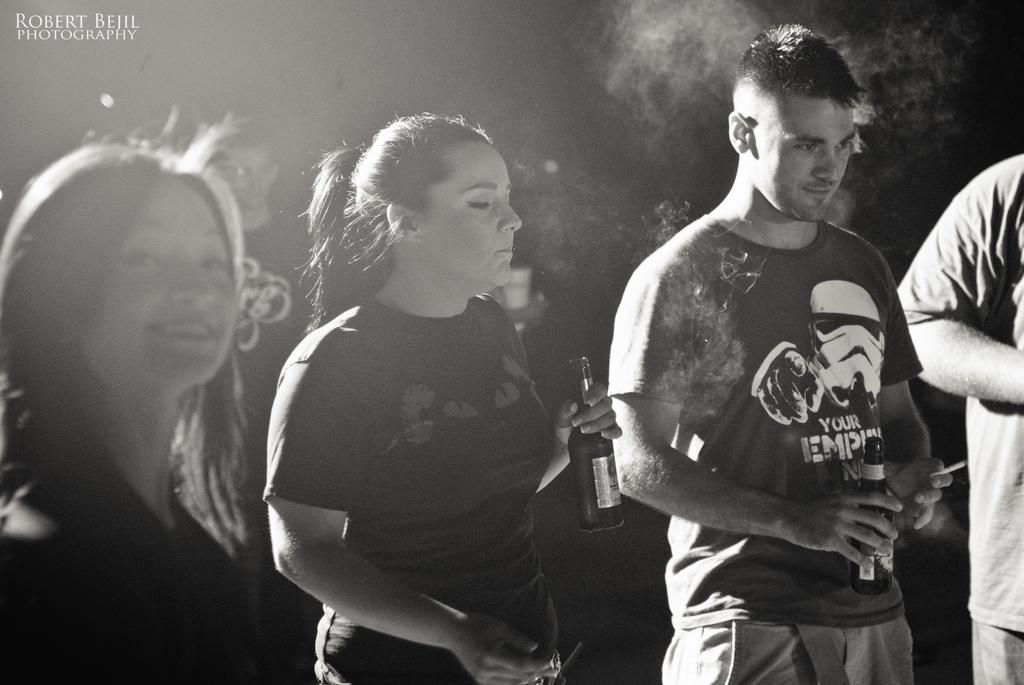How would you summarize this image in a sentence or two? In this picture there is a girl in the center of the image, by holding a bottle in her hand and there are other people on the right and left side of the image, there is smoke at the top side of the image. 